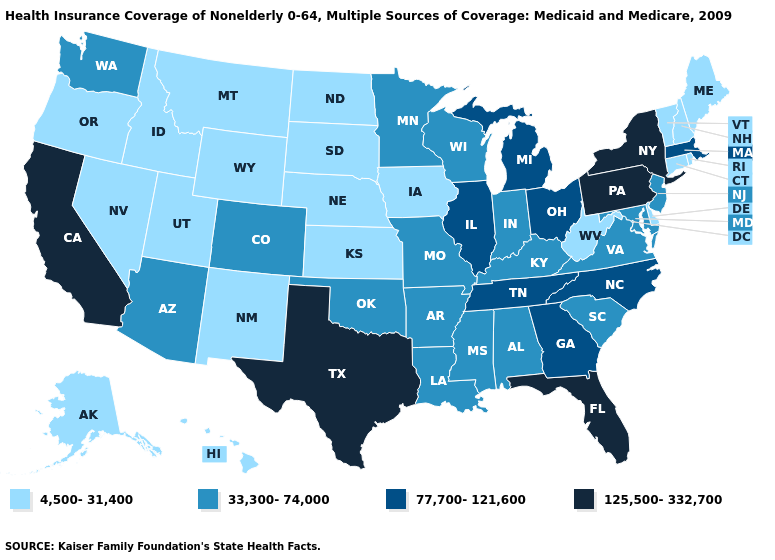Does the map have missing data?
Concise answer only. No. Does Indiana have a higher value than Florida?
Write a very short answer. No. Does Idaho have a higher value than Tennessee?
Be succinct. No. What is the value of Michigan?
Quick response, please. 77,700-121,600. Name the states that have a value in the range 125,500-332,700?
Answer briefly. California, Florida, New York, Pennsylvania, Texas. Name the states that have a value in the range 77,700-121,600?
Be succinct. Georgia, Illinois, Massachusetts, Michigan, North Carolina, Ohio, Tennessee. What is the value of Louisiana?
Answer briefly. 33,300-74,000. Does Hawaii have the same value as Maine?
Answer briefly. Yes. What is the value of Alabama?
Quick response, please. 33,300-74,000. Does the map have missing data?
Answer briefly. No. Does Oregon have a lower value than Nebraska?
Concise answer only. No. What is the value of Louisiana?
Quick response, please. 33,300-74,000. Does Arizona have a higher value than Wyoming?
Short answer required. Yes. What is the lowest value in states that border Missouri?
Concise answer only. 4,500-31,400. What is the value of Connecticut?
Answer briefly. 4,500-31,400. 